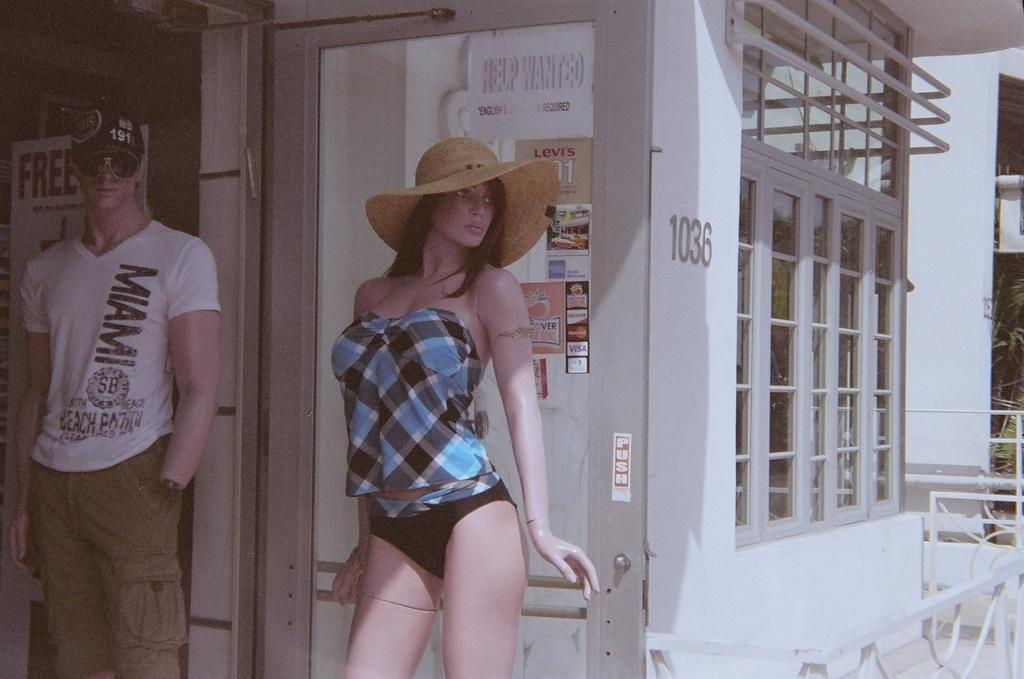How many mannequins are in the image? There are two mannequins in the image. What can be seen in the background of the image? There is a building and a door with posters in the background of the image. What is written on the posters? There is text on the posters. Can you see any ants crawling on the mannequins in the image? There are no ants visible on the mannequins in the image. What type of mountain is in the background of the image? There is no mountain present in the background of the image. 